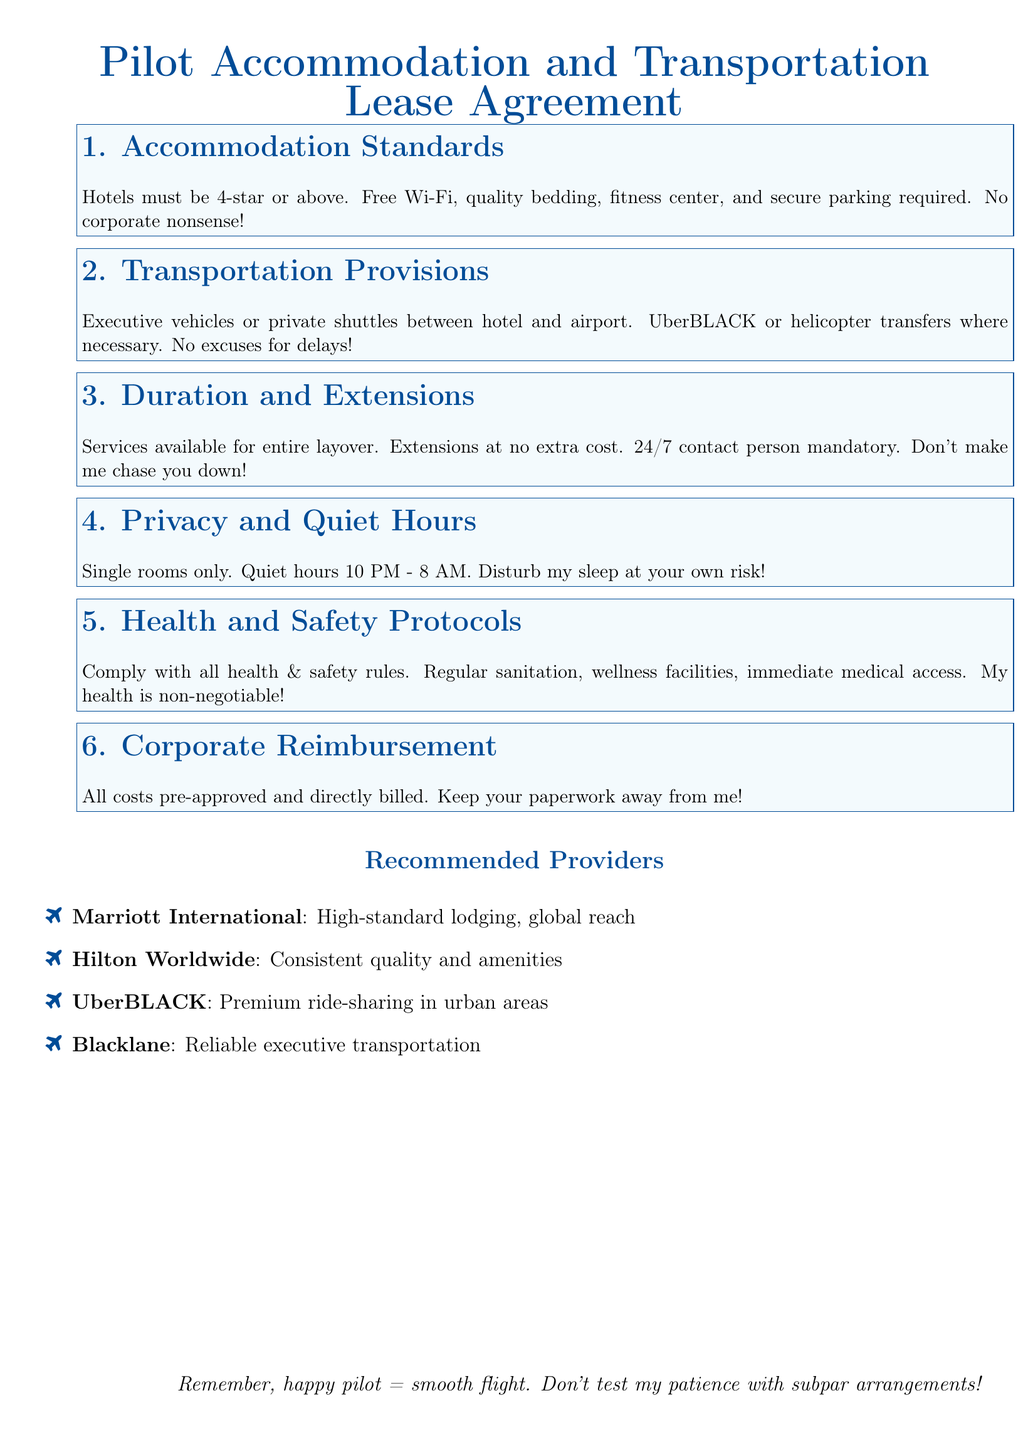What is the minimum hotel star rating required? The minimum hotel star rating required is stated in the Accommodation Standards section.
Answer: 4-star What type of transportation is mentioned for airport transfers? The types of transportation mentioned include executive vehicles and private shuttles in the Transportation Provisions section.
Answer: Executive vehicles or private shuttles What is the duration of services available for layovers? The duration of services for layovers is specified in the Duration and Extensions section of the document.
Answer: Entire layover What are the quiet hours specified in the agreement? The quiet hours are listed in the Privacy and Quiet Hours section.
Answer: 10 PM - 8 AM What is required for health and safety compliance? The Health and Safety Protocols section outlines requirements for health and safety compliance.
Answer: Regular sanitation What is the consequence of disturbing the pilot's sleep? The consequence of disturbing the pilot's sleep is mentioned in a firm tone in the Privacy and Quiet Hours section.
Answer: At your own risk What type of accommodation provider is mentioned first? The first accommodation provider mentioned in the Recommended Providers section is Marriott International.
Answer: Marriott International What is the key phrase emphasizing the pilot's happiness? The key phrase emphasizes the importance of the pilot's happiness in the document's closing statement.
Answer: Happy pilot = smooth flight 